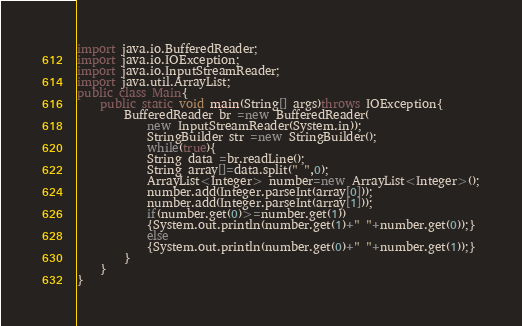Convert code to text. <code><loc_0><loc_0><loc_500><loc_500><_Java_>import java.io.BufferedReader;
import java.io.IOException;
import java.io.InputStreamReader;
import java.util.ArrayList;
public class Main{
    public static void main(String[] args)throws IOException{
        BufferedReader br =new BufferedReader(
            new InputStreamReader(System.in));
            StringBuilder str =new StringBuilder();
            while(true){
            String data =br.readLine();
            String array[]=data.split(" ",0);
            ArrayList<Integer> number=new ArrayList<Integer>();
            number.add(Integer.parseInt(array[0]));
            number.add(Integer.parseInt(array[1]));
            if(number.get(0)>=number.get(1))
            {System.out.println(number.get(1)+" "+number.get(0));}
            else
            {System.out.println(number.get(0)+" "+number.get(1));}
        }
    }
}</code> 